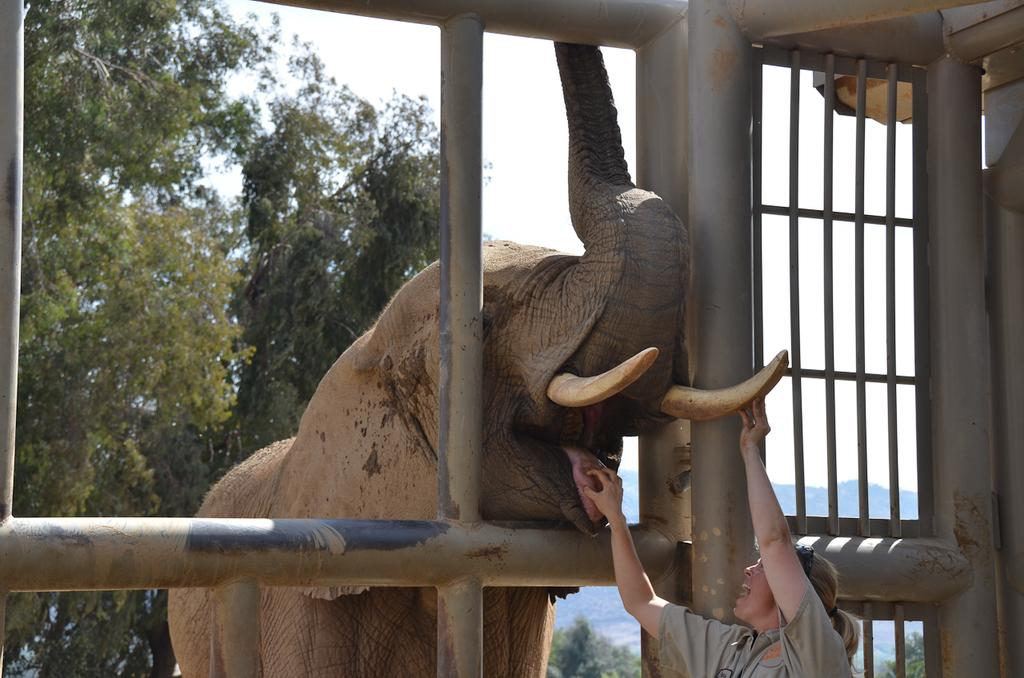What is located in the center of the image? There is a fence in the center of the image. What type of animal is in the image? There is an elephant in the image. What is the woman doing in the image? The woman is standing and holding the elephant's tongue. What can be seen in the background of the image? The sky, clouds, a hill, and trees are visible in the background of the image. Where is the faucet located in the image? There is no faucet present in the image. What is the name of the downtown area visible in the image? There is no downtown area visible in the image. 